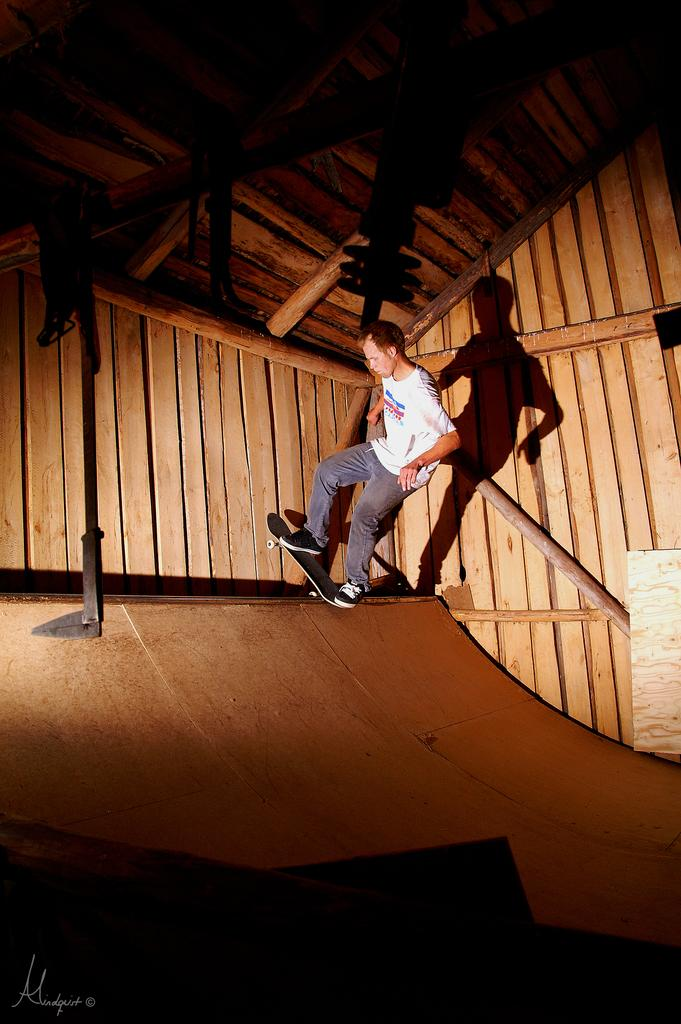Who is the main subject in the image? There is a man in the image. What is the man doing in the image? The man is skating in the image. What can be seen at the bottom of the image? There is a ramp at the bottom of the image. What type of material is used for the walls in the background of the image? The walls in the background of the image are made of wood. Where are the dolls placed in the image? There are no dolls present in the image. How many bikes can be seen in the image? There are no bikes visible in the image. 